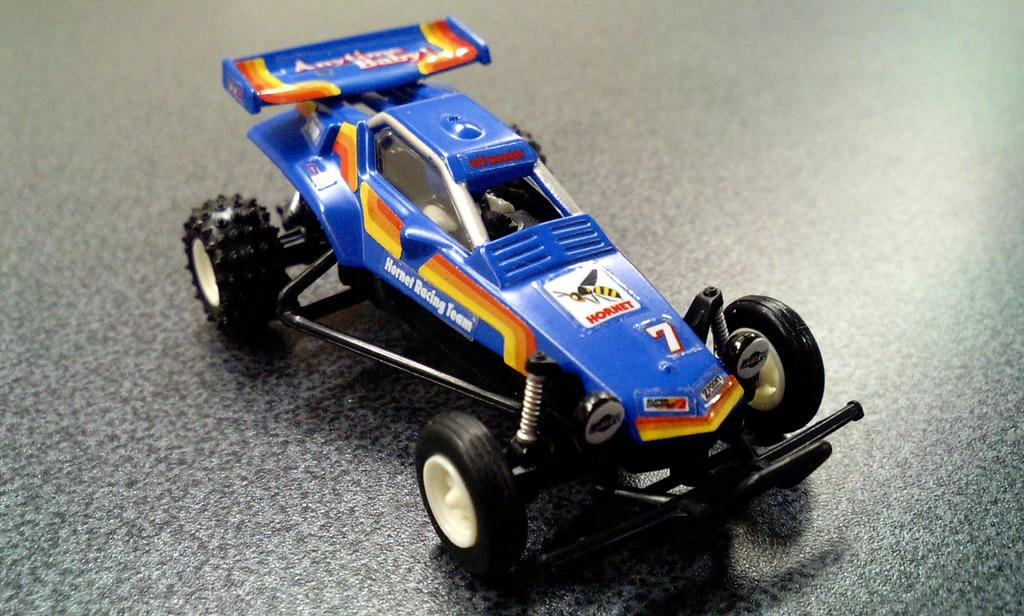What type of toy is in the center of the image? There is a blue color Go-kart toy in the image. Where is the Go-kart toy located in relation to the ground? The Go-kart toy is placed on the ground. What type of railway system is visible in the image? There is no railway system present in the image; it features a blue color Go-kart toy placed on the ground. How many boats are visible in the image? There are no boats present in the image. 